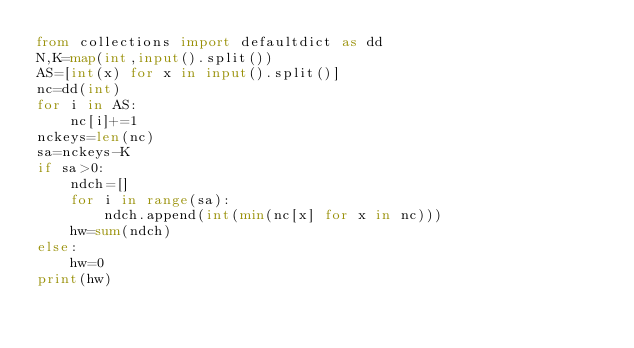Convert code to text. <code><loc_0><loc_0><loc_500><loc_500><_Python_>from collections import defaultdict as dd
N,K=map(int,input().split())
AS=[int(x) for x in input().split()]
nc=dd(int)
for i in AS:
    nc[i]+=1
nckeys=len(nc)
sa=nckeys-K
if sa>0:
    ndch=[]
    for i in range(sa):
        ndch.append(int(min(nc[x] for x in nc)))
    hw=sum(ndch)
else:
    hw=0
print(hw)</code> 